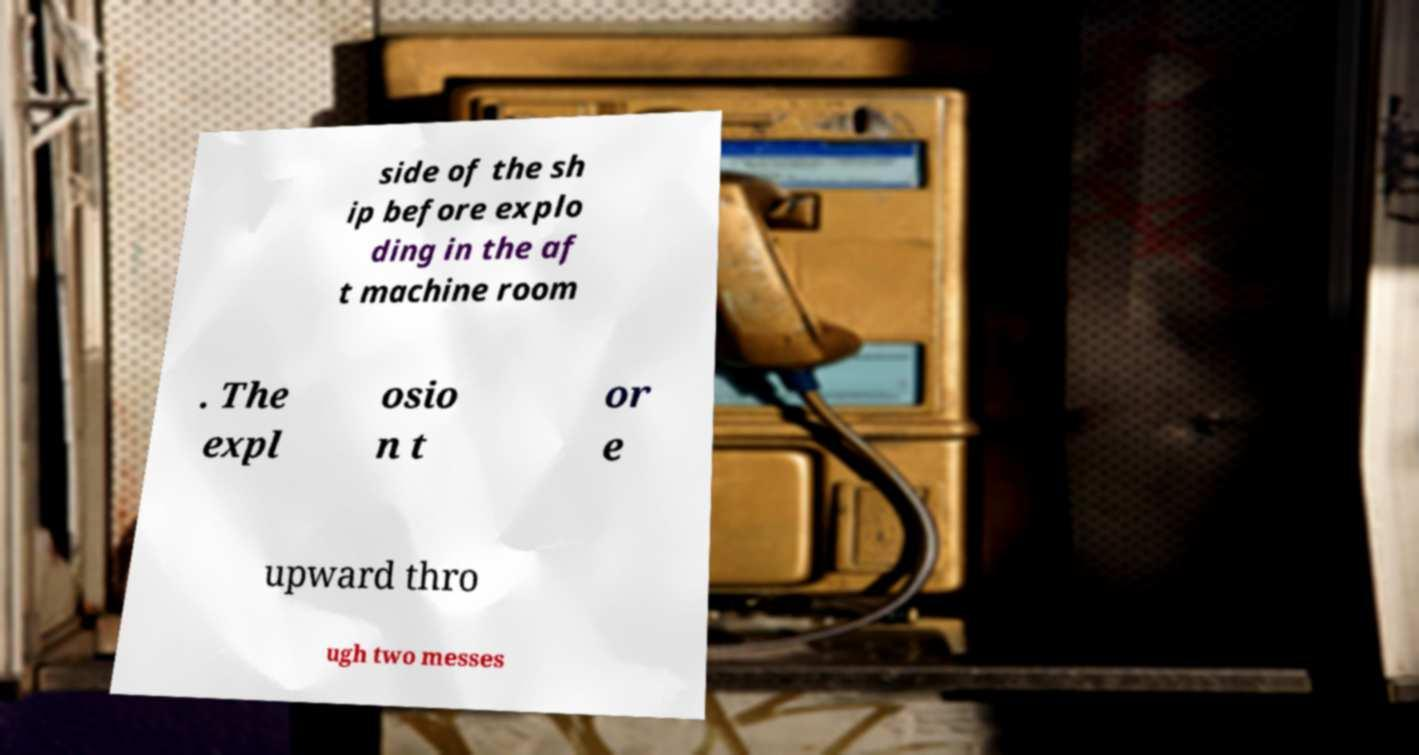For documentation purposes, I need the text within this image transcribed. Could you provide that? side of the sh ip before explo ding in the af t machine room . The expl osio n t or e upward thro ugh two messes 